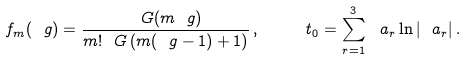Convert formula to latex. <formula><loc_0><loc_0><loc_500><loc_500>f _ { m } ( \ g ) = \frac { \ G ( m \ g ) } { m ! \ G \left ( m ( \ g - 1 ) + 1 \right ) } \, , \quad \ t _ { 0 } = \sum _ { r = 1 } ^ { 3 } \ a _ { r } \ln | \ a _ { r } | \, .</formula> 